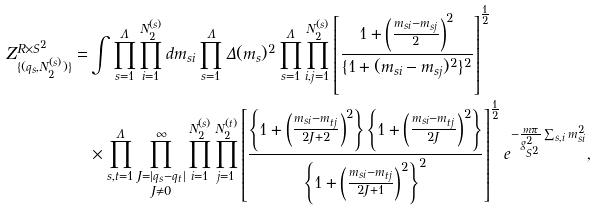Convert formula to latex. <formula><loc_0><loc_0><loc_500><loc_500>Z _ { \{ ( q _ { s } , N _ { 2 } ^ { ( s ) } ) \} } ^ { R \times S ^ { 2 } } = & \int \prod _ { s = 1 } ^ { \Lambda } \prod _ { i = 1 } ^ { N _ { 2 } ^ { ( s ) } } d m _ { s i } \prod _ { s = 1 } ^ { \Lambda } \Delta ( m _ { s } ) ^ { 2 } \prod _ { s = 1 } ^ { \Lambda } \prod _ { i , j = 1 } ^ { N _ { 2 } ^ { ( s ) } } \left [ \frac { 1 + \left ( \frac { m _ { s i } - m _ { s j } } { 2 } \right ) ^ { 2 } } { \{ 1 + ( m _ { s i } - m _ { s j } ) ^ { 2 } \} ^ { 2 } } \right ] ^ { \frac { 1 } { 2 } } \\ & \times \prod _ { s , t = 1 } ^ { \Lambda } \prod _ { \substack { J = | q _ { s } - q _ { t } | \\ J \neq 0 } } ^ { \infty } \prod _ { i = 1 } ^ { N _ { 2 } ^ { ( s ) } } \prod _ { j = 1 } ^ { N _ { 2 } ^ { ( t ) } } \left [ \frac { \left \{ 1 + \left ( \frac { m _ { s i } - m _ { t j } } { 2 J + 2 } \right ) ^ { 2 } \right \} \left \{ 1 + \left ( \frac { m _ { s i } - m _ { t j } } { 2 J } \right ) ^ { 2 } \right \} } { \left \{ 1 + \left ( \frac { m _ { s i } - m _ { t j } } { 2 J + 1 } \right ) ^ { 2 } \right \} ^ { 2 } } \right ] ^ { \frac { 1 } { 2 } } e ^ { - \frac { m \pi } { g _ { S ^ { 2 } } ^ { 2 } } \sum _ { s , i } m _ { s i } ^ { 2 } } ,</formula> 